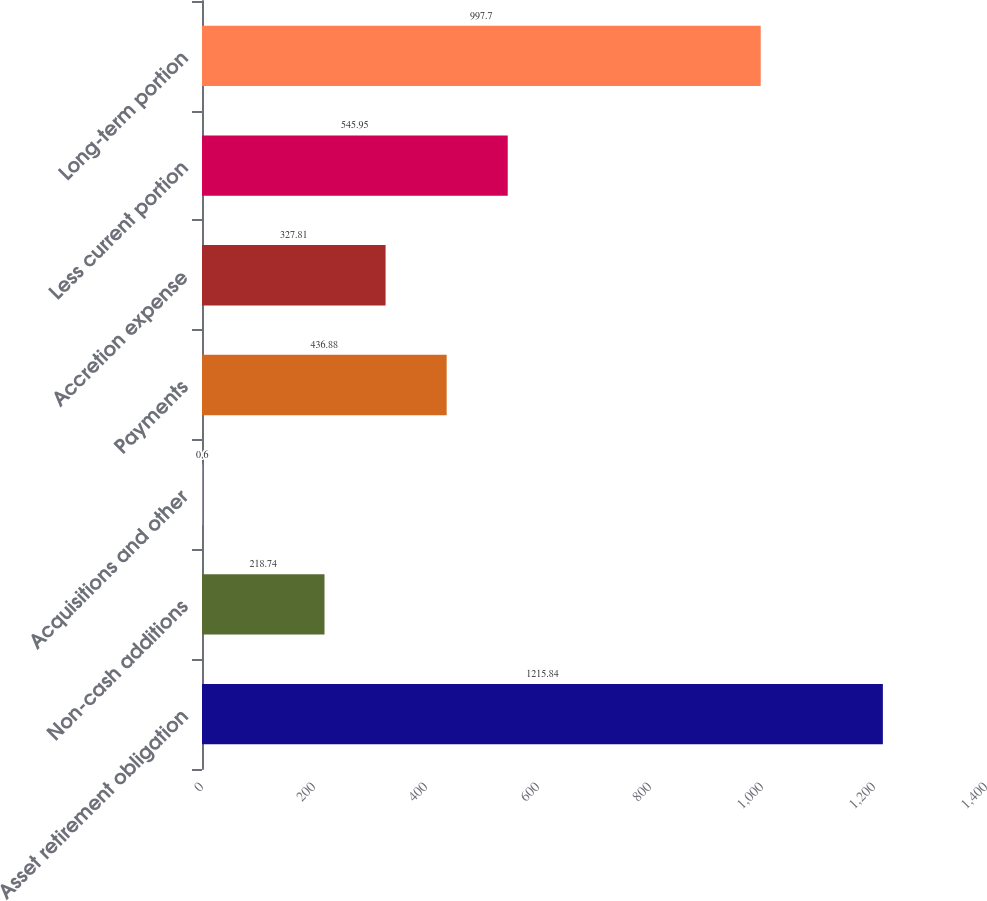<chart> <loc_0><loc_0><loc_500><loc_500><bar_chart><fcel>Asset retirement obligation<fcel>Non-cash additions<fcel>Acquisitions and other<fcel>Payments<fcel>Accretion expense<fcel>Less current portion<fcel>Long-term portion<nl><fcel>1215.84<fcel>218.74<fcel>0.6<fcel>436.88<fcel>327.81<fcel>545.95<fcel>997.7<nl></chart> 